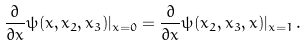<formula> <loc_0><loc_0><loc_500><loc_500>\frac { \partial } { \partial x } \psi ( x , x _ { 2 } , x _ { 3 } ) | _ { x = 0 } = \frac { \partial } { \partial x } \psi ( x _ { 2 } , x _ { 3 } , x ) | _ { x = 1 } \, .</formula> 